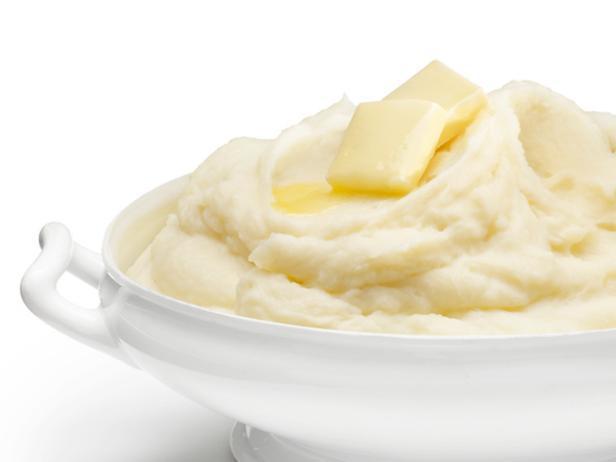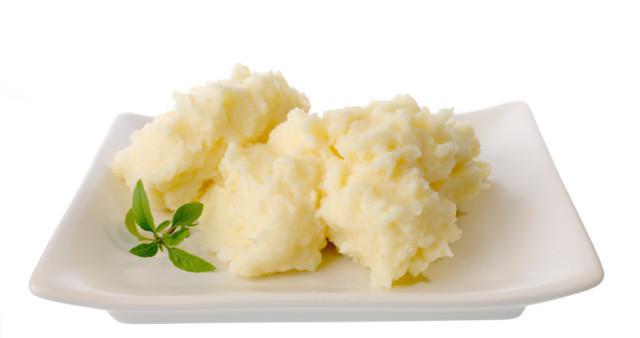The first image is the image on the left, the second image is the image on the right. Analyze the images presented: Is the assertion "herbs are sprinkled over the mashed potato" valid? Answer yes or no. No. The first image is the image on the left, the second image is the image on the right. Given the left and right images, does the statement "The mashed potatoes are in a bowl in one image, and on a plate in the other." hold true? Answer yes or no. Yes. 